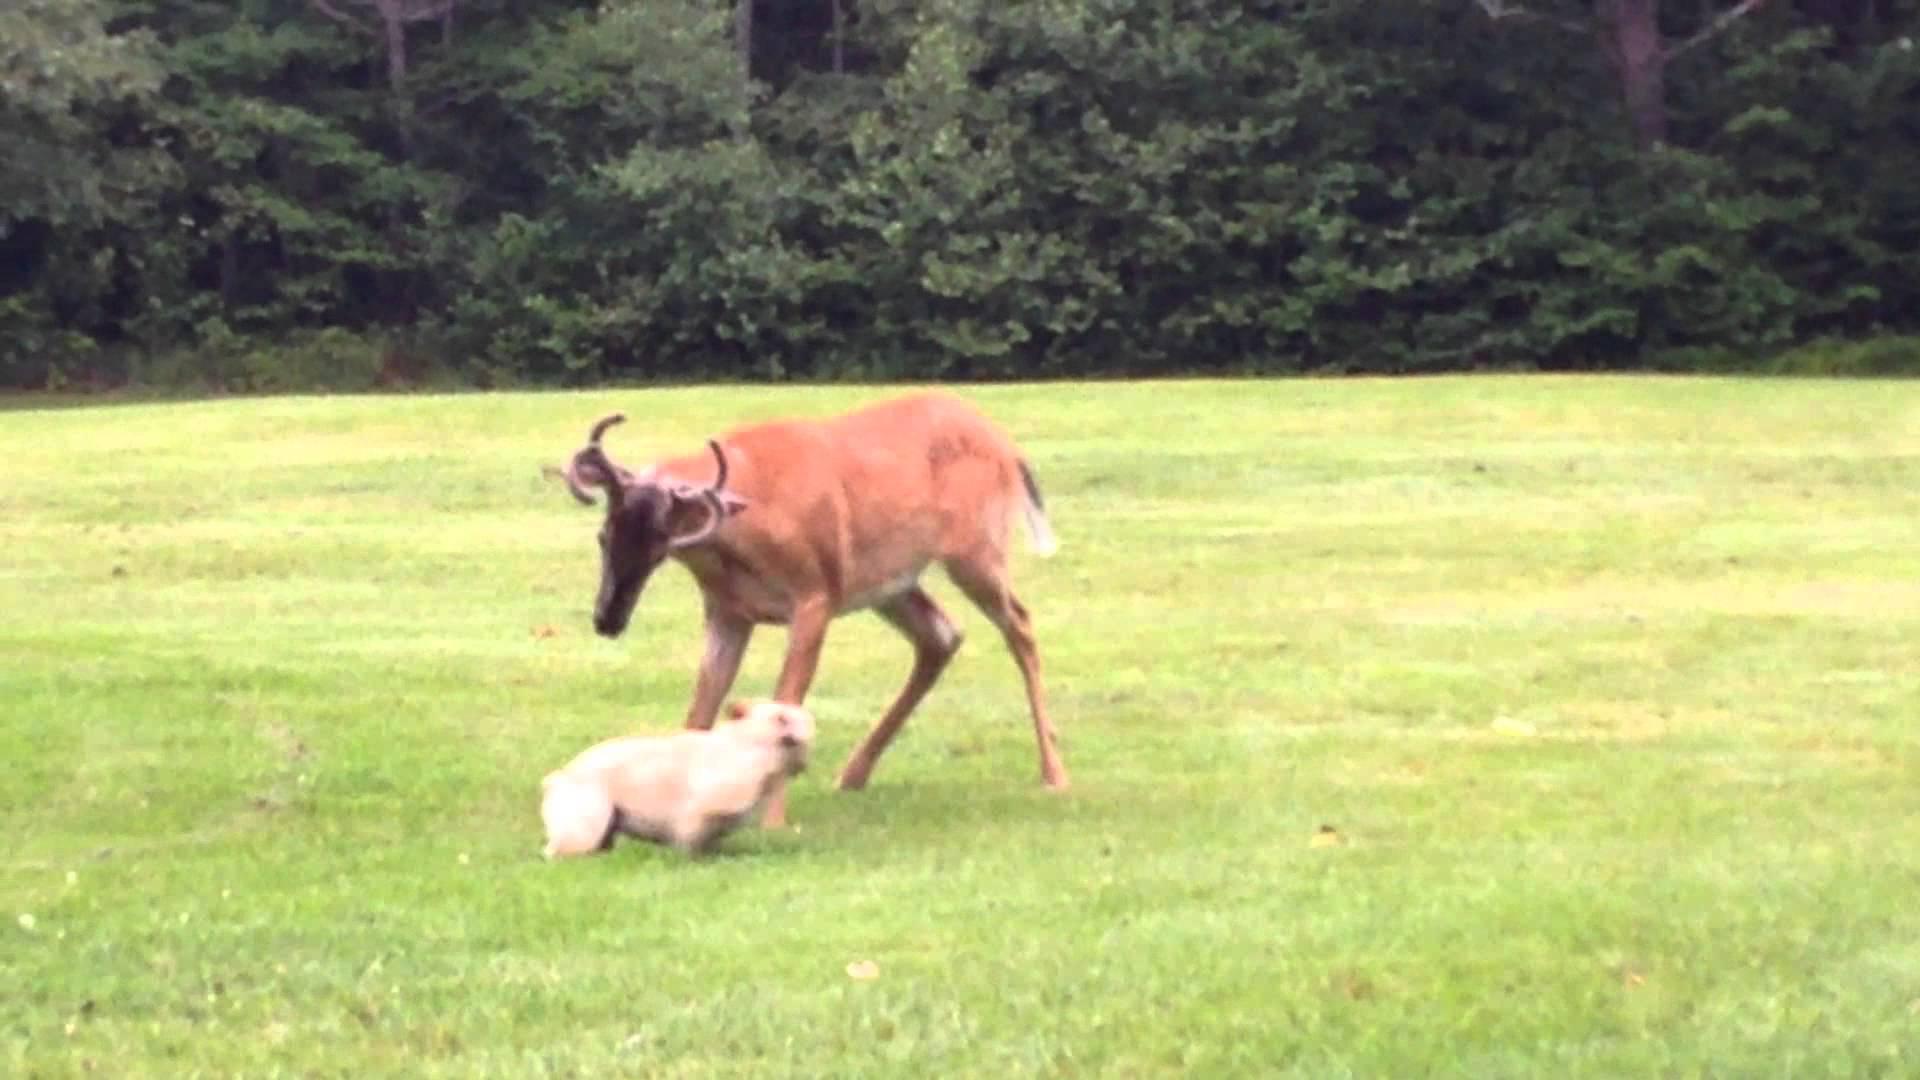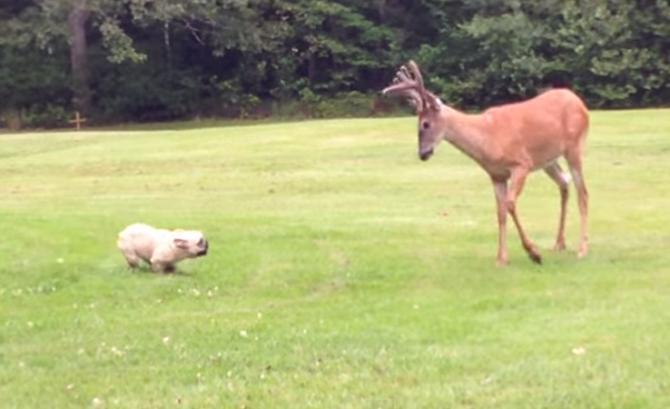The first image is the image on the left, the second image is the image on the right. For the images displayed, is the sentence "A total of one French Bulldog has something in its mouth." factually correct? Answer yes or no. No. The first image is the image on the left, the second image is the image on the right. For the images shown, is this caption "Each picture includes more than one mammal." true? Answer yes or no. Yes. 